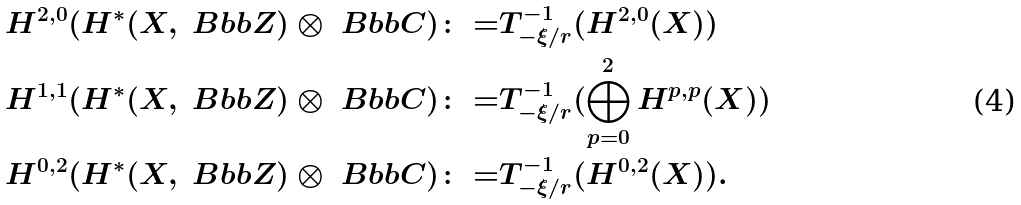Convert formula to latex. <formula><loc_0><loc_0><loc_500><loc_500>H ^ { 2 , 0 } ( H ^ { * } ( X , { \ B b b Z } ) \otimes { \ B b b C } ) \colon = & T _ { - \xi / r } ^ { - 1 } ( H ^ { 2 , 0 } ( X ) ) \\ H ^ { 1 , 1 } ( H ^ { * } ( X , { \ B b b Z } ) \otimes { \ B b b C } ) \colon = & T _ { - \xi / r } ^ { - 1 } ( \bigoplus _ { p = 0 } ^ { 2 } H ^ { p , p } ( X ) ) \\ H ^ { 0 , 2 } ( H ^ { * } ( X , { \ B b b Z } ) \otimes { \ B b b C } ) \colon = & T _ { - \xi / r } ^ { - 1 } ( H ^ { 0 , 2 } ( X ) ) .</formula> 